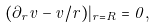Convert formula to latex. <formula><loc_0><loc_0><loc_500><loc_500>( \partial _ { r } v - v / r ) | _ { r = R } = 0 ,</formula> 